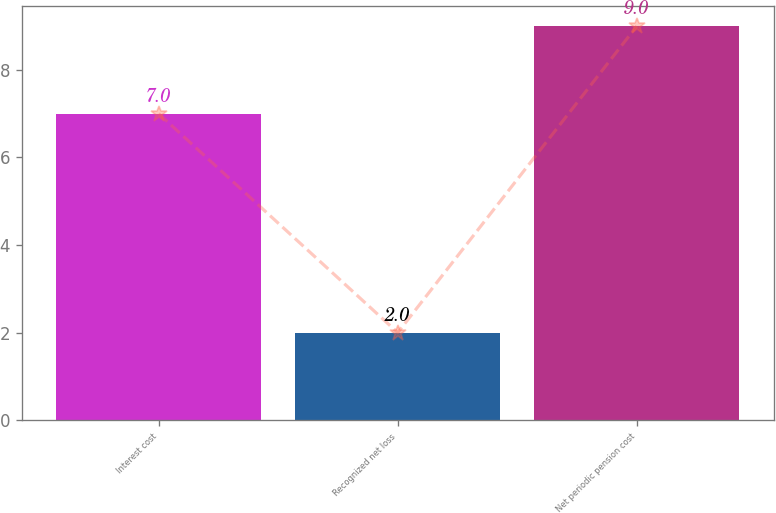Convert chart to OTSL. <chart><loc_0><loc_0><loc_500><loc_500><bar_chart><fcel>Interest cost<fcel>Recognized net loss<fcel>Net periodic pension cost<nl><fcel>7<fcel>2<fcel>9<nl></chart> 